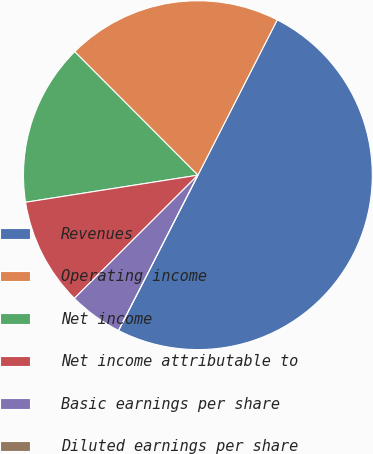Convert chart to OTSL. <chart><loc_0><loc_0><loc_500><loc_500><pie_chart><fcel>Revenues<fcel>Operating income<fcel>Net income<fcel>Net income attributable to<fcel>Basic earnings per share<fcel>Diluted earnings per share<nl><fcel>50.0%<fcel>20.0%<fcel>15.0%<fcel>10.0%<fcel>5.0%<fcel>0.0%<nl></chart> 